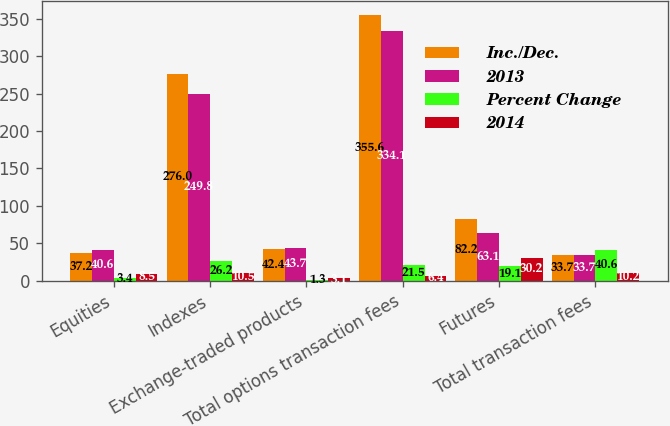Convert chart to OTSL. <chart><loc_0><loc_0><loc_500><loc_500><stacked_bar_chart><ecel><fcel>Equities<fcel>Indexes<fcel>Exchange-traded products<fcel>Total options transaction fees<fcel>Futures<fcel>Total transaction fees<nl><fcel>Inc./Dec.<fcel>37.2<fcel>276<fcel>42.4<fcel>355.6<fcel>82.2<fcel>33.7<nl><fcel>2013<fcel>40.6<fcel>249.8<fcel>43.7<fcel>334.1<fcel>63.1<fcel>33.7<nl><fcel>Percent Change<fcel>3.4<fcel>26.2<fcel>1.3<fcel>21.5<fcel>19.1<fcel>40.6<nl><fcel>2014<fcel>8.5<fcel>10.5<fcel>3.1<fcel>6.4<fcel>30.2<fcel>10.2<nl></chart> 